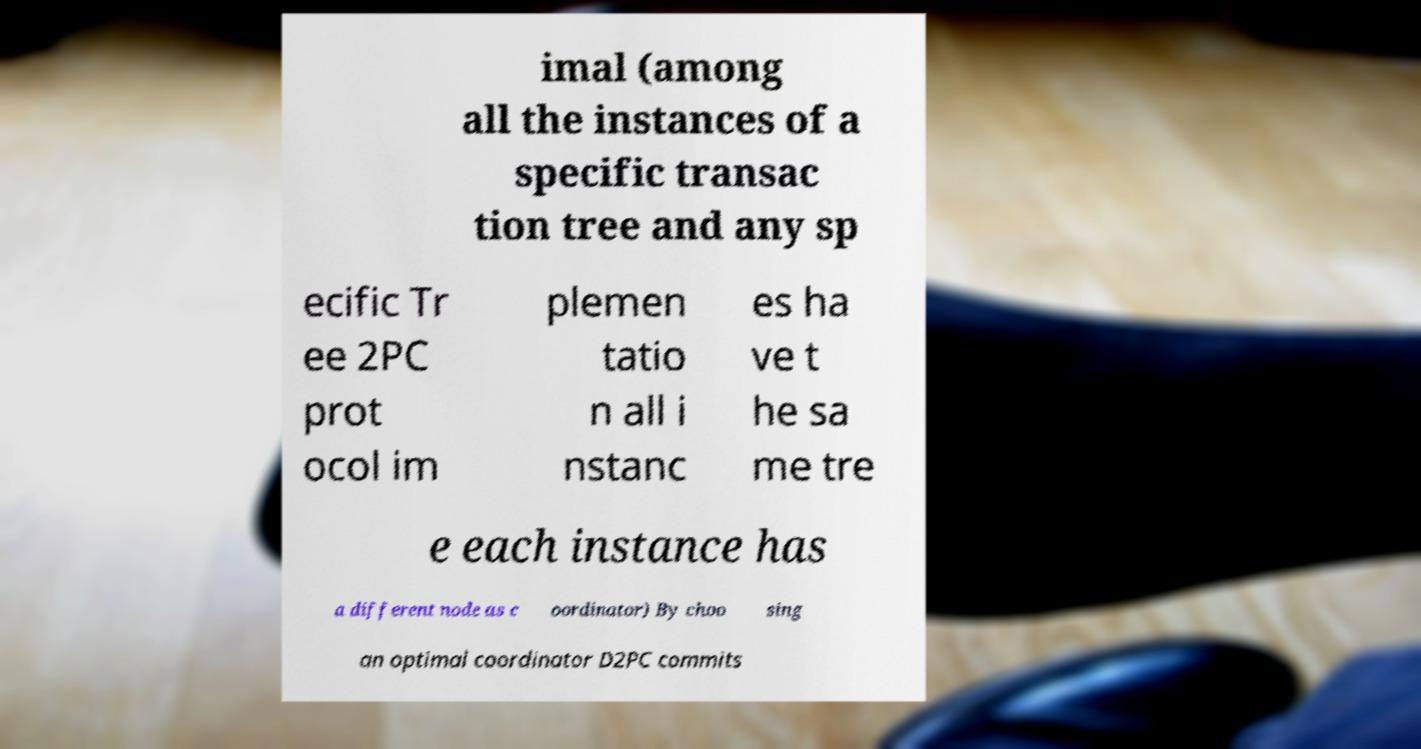Please read and relay the text visible in this image. What does it say? imal (among all the instances of a specific transac tion tree and any sp ecific Tr ee 2PC prot ocol im plemen tatio n all i nstanc es ha ve t he sa me tre e each instance has a different node as c oordinator) By choo sing an optimal coordinator D2PC commits 